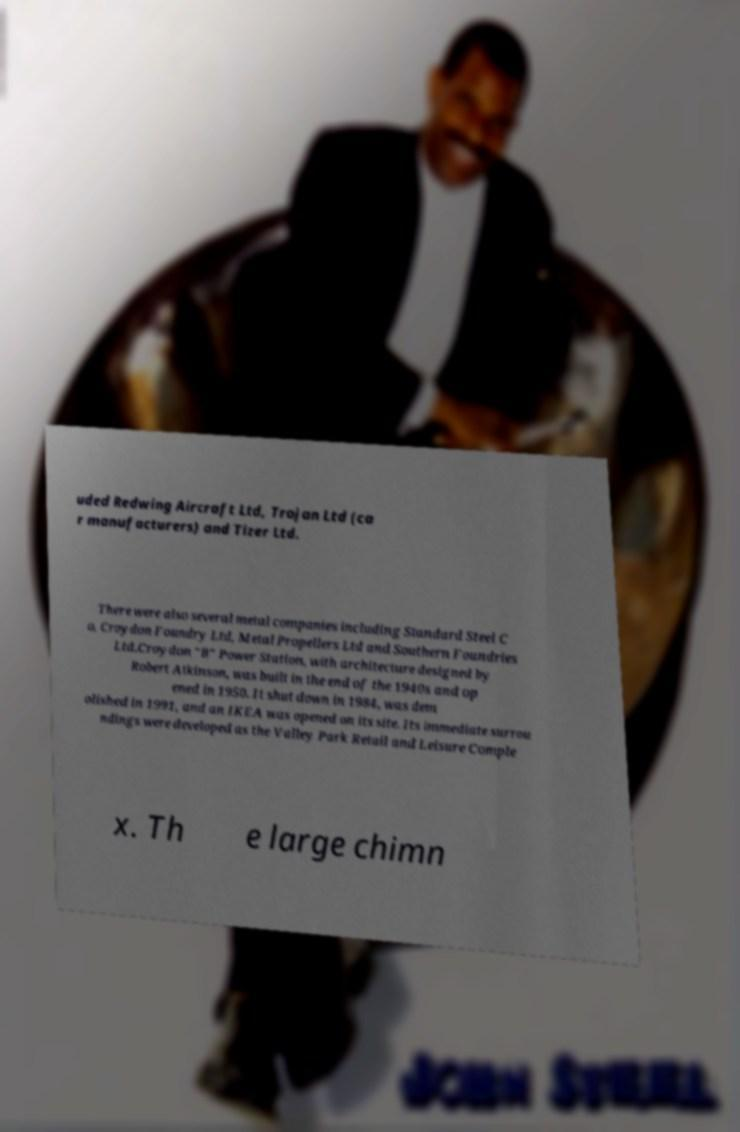What messages or text are displayed in this image? I need them in a readable, typed format. uded Redwing Aircraft Ltd, Trojan Ltd (ca r manufacturers) and Tizer Ltd. There were also several metal companies including Standard Steel C o, Croydon Foundry Ltd, Metal Propellers Ltd and Southern Foundries Ltd.Croydon "B" Power Station, with architecture designed by Robert Atkinson, was built in the end of the 1940s and op ened in 1950. It shut down in 1984, was dem olished in 1991, and an IKEA was opened on its site. Its immediate surrou ndings were developed as the Valley Park Retail and Leisure Comple x. Th e large chimn 